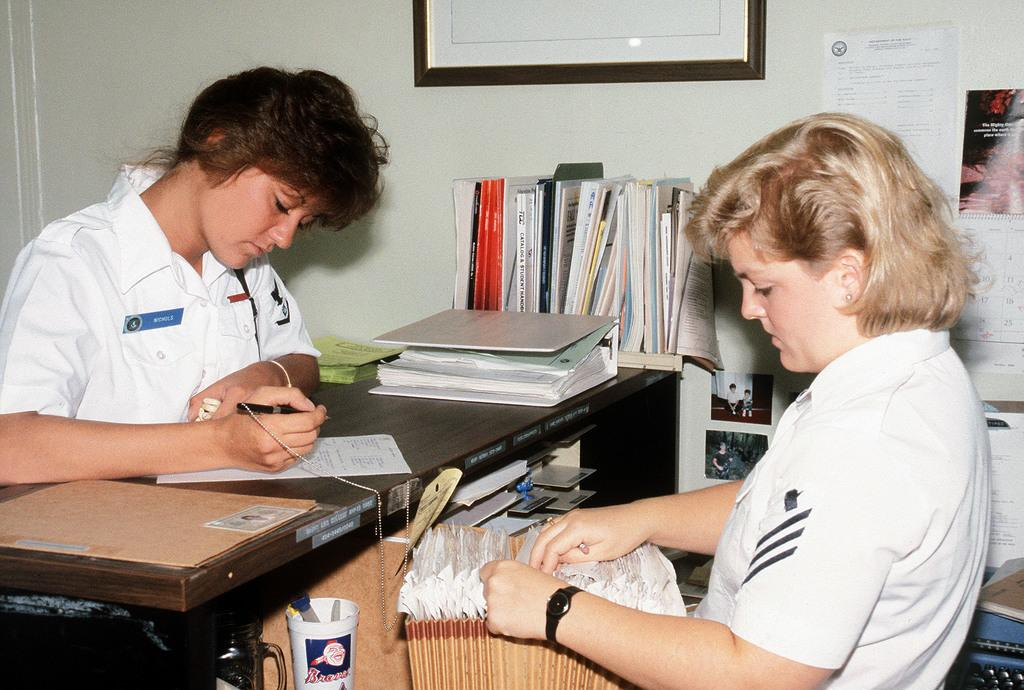How many women are present in the image? There are two women in the image. What is one of the women doing in the image? One of the women is writing on a paper. What is the other woman doing in the image? The other woman is searching for paper. What type of goat can be seen in the image? There is no goat present in the image. Is the paper the woman is writing on for a birthday celebration? The facts provided do not mention any birthday celebration, so it cannot be determined from the image. 